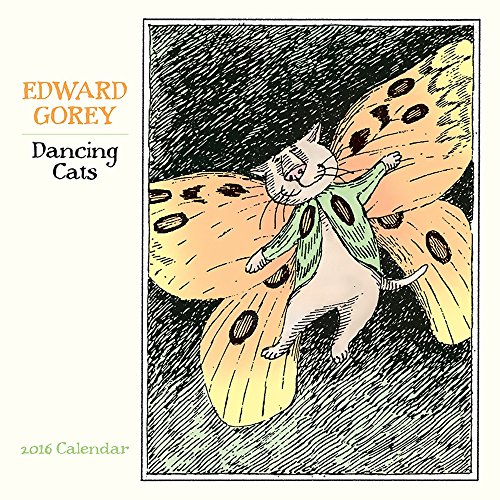What does the cat's posture in this illustration suggest about its mood or activity? The cat's uplifted paws and wide-spread 'wings' give it a sense of jubilation and whimsy, as if it is caught in a dance or a joyful leap, imbuing the illustration with a sense of dynamic movement and playful energy. 